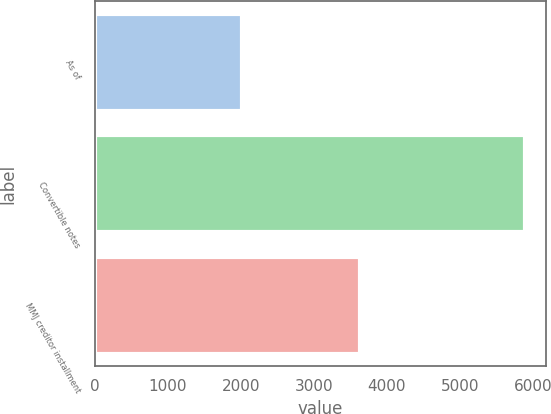<chart> <loc_0><loc_0><loc_500><loc_500><bar_chart><fcel>As of<fcel>Convertible notes<fcel>MMJ creditor installment<nl><fcel>2014<fcel>5886<fcel>3634<nl></chart> 